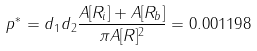Convert formula to latex. <formula><loc_0><loc_0><loc_500><loc_500>p ^ { * } = d _ { 1 } d _ { 2 } \frac { A [ R _ { i } ] + A [ R _ { b } ] } { \pi A [ R ] ^ { 2 } } = 0 . 0 0 1 1 9 8</formula> 